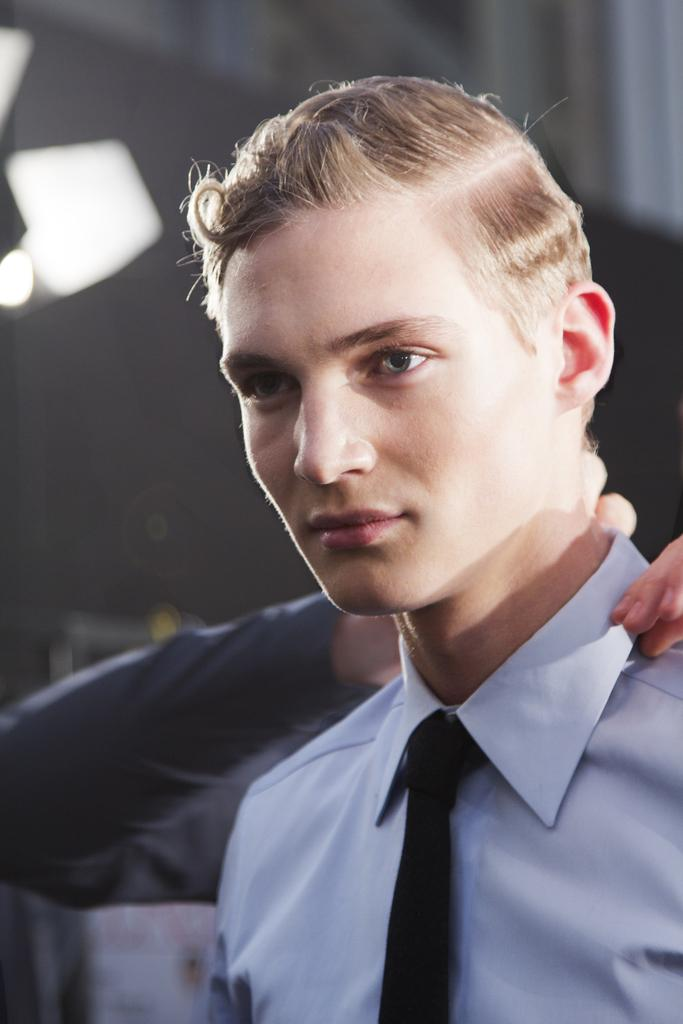What is present in the image? There is a person in the image. What is the person doing in the image? The person is looking to one side. What is the person wearing in the image? The person is wearing a shirt and a tie. Can you describe the second person in the image? There is another person behind the first person, and they are adjusting the first person's collar. What type of grass can be seen growing in the image? There is no grass present in the image; it features two people, one of whom is adjusting the other's collar. 